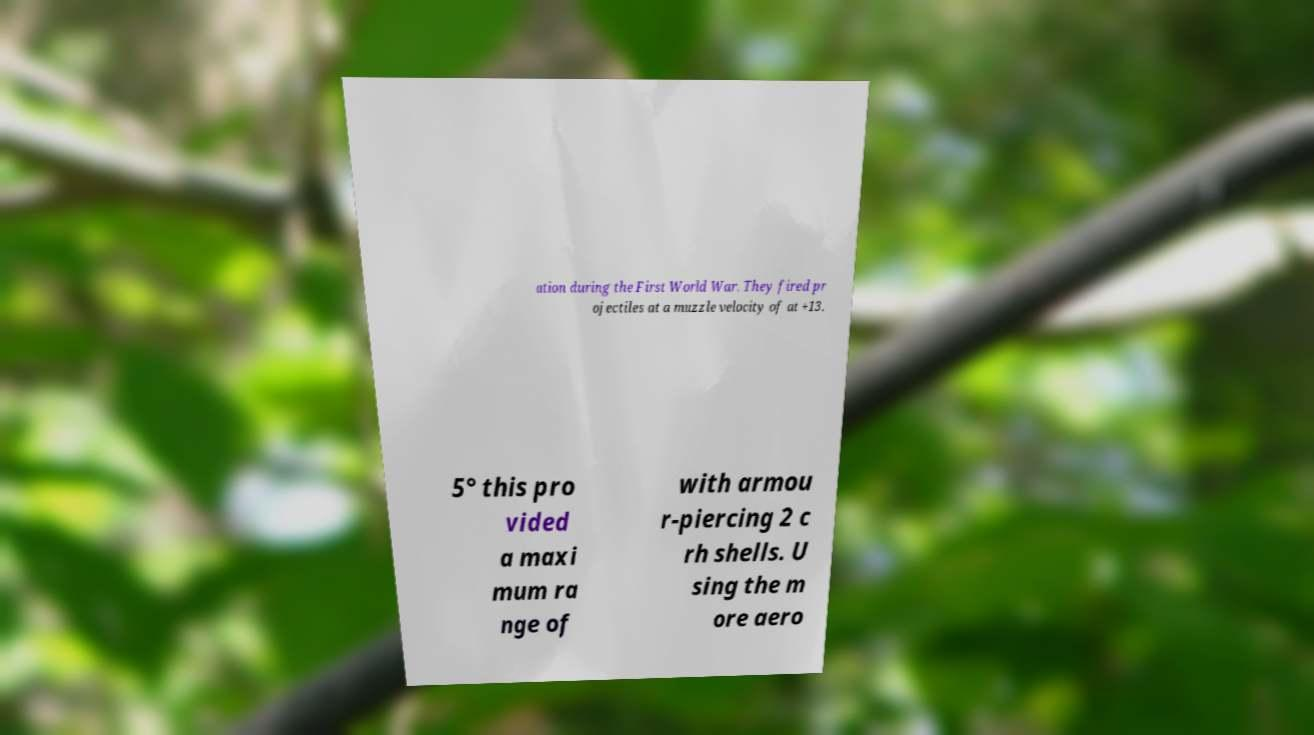For documentation purposes, I need the text within this image transcribed. Could you provide that? ation during the First World War. They fired pr ojectiles at a muzzle velocity of at +13. 5° this pro vided a maxi mum ra nge of with armou r-piercing 2 c rh shells. U sing the m ore aero 